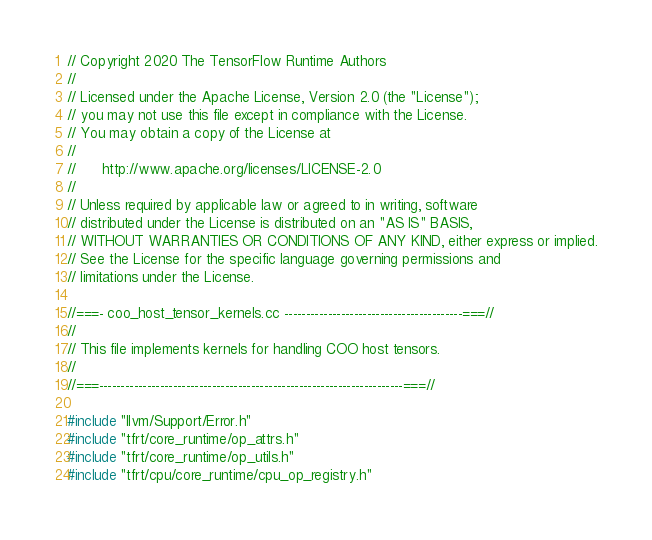<code> <loc_0><loc_0><loc_500><loc_500><_C++_>// Copyright 2020 The TensorFlow Runtime Authors
//
// Licensed under the Apache License, Version 2.0 (the "License");
// you may not use this file except in compliance with the License.
// You may obtain a copy of the License at
//
//      http://www.apache.org/licenses/LICENSE-2.0
//
// Unless required by applicable law or agreed to in writing, software
// distributed under the License is distributed on an "AS IS" BASIS,
// WITHOUT WARRANTIES OR CONDITIONS OF ANY KIND, either express or implied.
// See the License for the specific language governing permissions and
// limitations under the License.

//===- coo_host_tensor_kernels.cc -----------------------------------------===//
//
// This file implements kernels for handling COO host tensors.
//
//===----------------------------------------------------------------------===//

#include "llvm/Support/Error.h"
#include "tfrt/core_runtime/op_attrs.h"
#include "tfrt/core_runtime/op_utils.h"
#include "tfrt/cpu/core_runtime/cpu_op_registry.h"</code> 